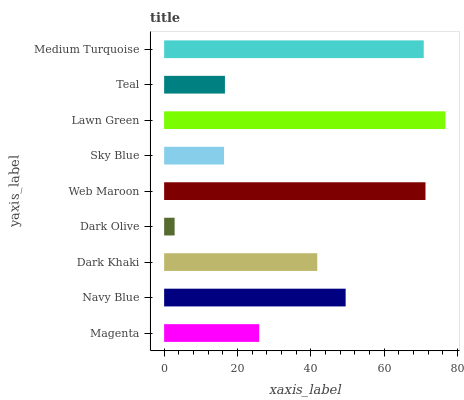Is Dark Olive the minimum?
Answer yes or no. Yes. Is Lawn Green the maximum?
Answer yes or no. Yes. Is Navy Blue the minimum?
Answer yes or no. No. Is Navy Blue the maximum?
Answer yes or no. No. Is Navy Blue greater than Magenta?
Answer yes or no. Yes. Is Magenta less than Navy Blue?
Answer yes or no. Yes. Is Magenta greater than Navy Blue?
Answer yes or no. No. Is Navy Blue less than Magenta?
Answer yes or no. No. Is Dark Khaki the high median?
Answer yes or no. Yes. Is Dark Khaki the low median?
Answer yes or no. Yes. Is Navy Blue the high median?
Answer yes or no. No. Is Medium Turquoise the low median?
Answer yes or no. No. 